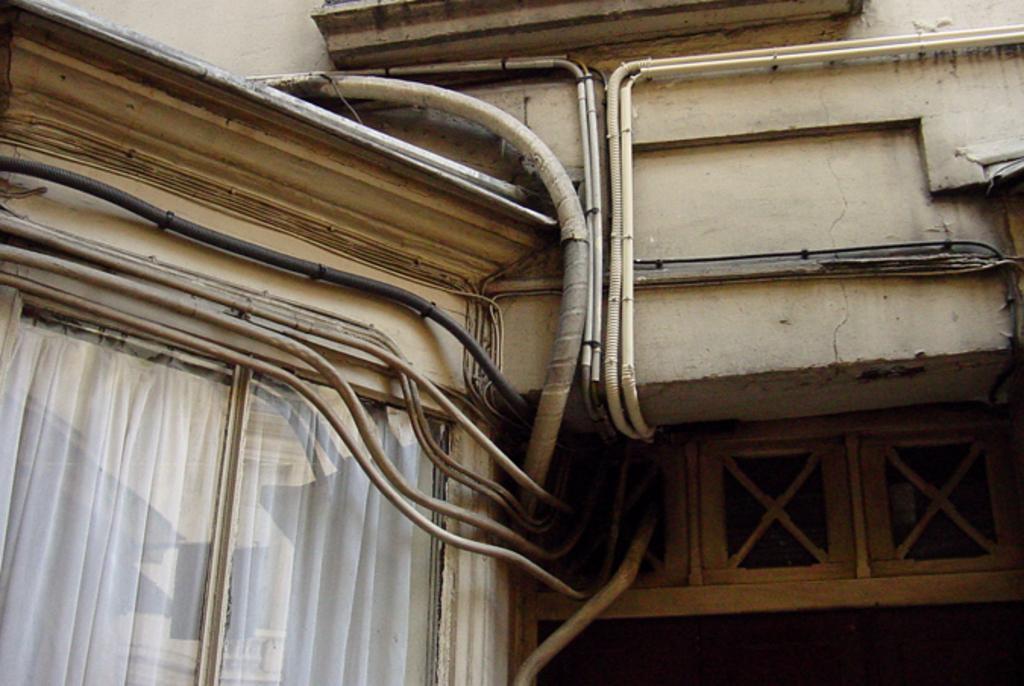Can you describe this image briefly? In this image I can see a building and number of wire pipes. I can also see a white color curtain on the bottom left side. 